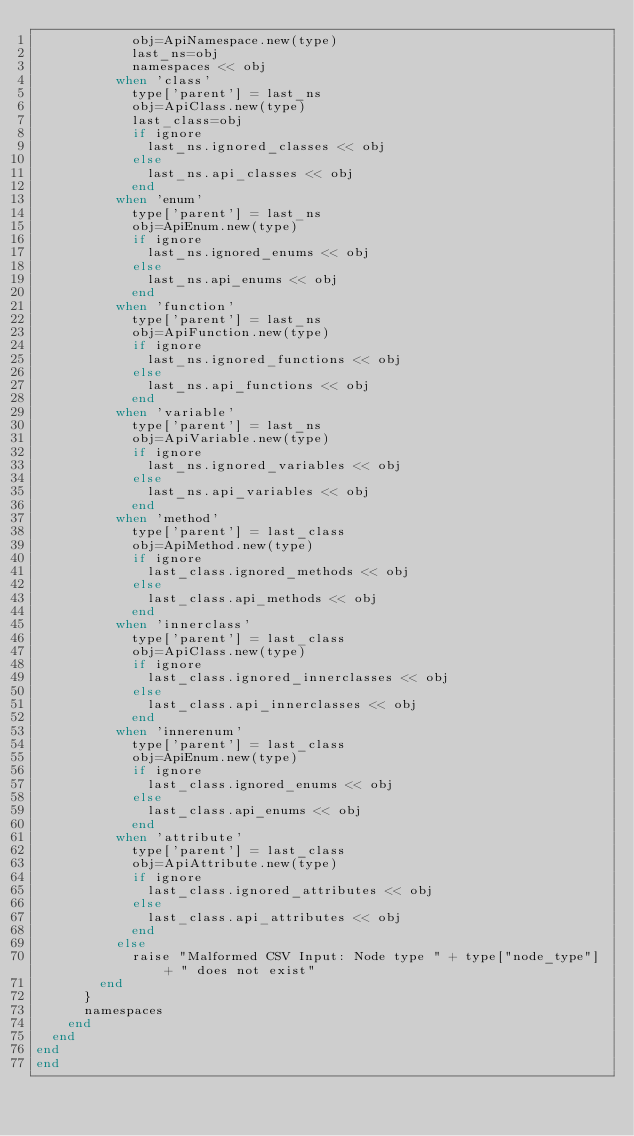Convert code to text. <code><loc_0><loc_0><loc_500><loc_500><_Ruby_>            obj=ApiNamespace.new(type)
            last_ns=obj
            namespaces << obj
          when 'class'
            type['parent'] = last_ns
            obj=ApiClass.new(type)
            last_class=obj            
            if ignore
              last_ns.ignored_classes << obj
            else
              last_ns.api_classes << obj
            end
          when 'enum'
            type['parent'] = last_ns
            obj=ApiEnum.new(type)
            if ignore
              last_ns.ignored_enums << obj
            else
              last_ns.api_enums << obj
            end            
          when 'function'
            type['parent'] = last_ns
            obj=ApiFunction.new(type)
            if ignore
              last_ns.ignored_functions << obj
            else
              last_ns.api_functions << obj
            end
          when 'variable'
            type['parent'] = last_ns
            obj=ApiVariable.new(type)
            if ignore
              last_ns.ignored_variables << obj
            else
              last_ns.api_variables << obj
            end
          when 'method'
            type['parent'] = last_class
            obj=ApiMethod.new(type)
            if ignore
              last_class.ignored_methods << obj
            else
              last_class.api_methods << obj
            end
          when 'innerclass'
            type['parent'] = last_class
            obj=ApiClass.new(type)
            if ignore
              last_class.ignored_innerclasses << obj
            else
              last_class.api_innerclasses << obj
            end            
          when 'innerenum'
            type['parent'] = last_class
            obj=ApiEnum.new(type)
            if ignore
              last_class.ignored_enums << obj
            else
              last_class.api_enums << obj
            end
          when 'attribute'
            type['parent'] = last_class
            obj=ApiAttribute.new(type)
            if ignore
              last_class.ignored_attributes << obj
            else
              last_class.api_attributes << obj
            end
          else
            raise "Malformed CSV Input: Node type " + type["node_type"] + " does not exist"
        end
      }
      namespaces
    end    
  end
end
end</code> 